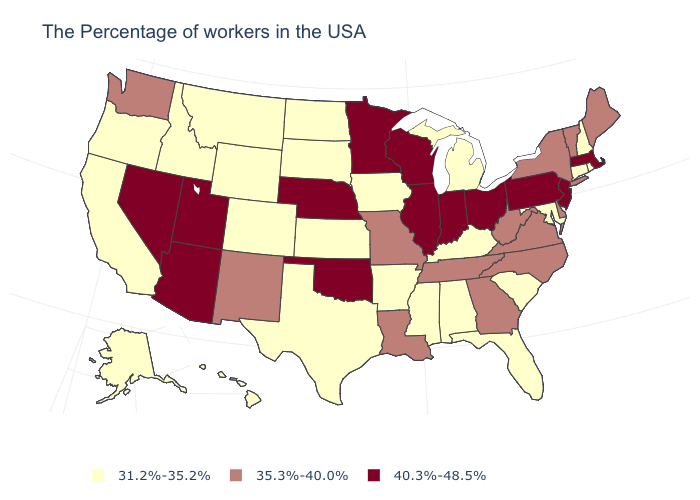What is the value of Connecticut?
Keep it brief. 31.2%-35.2%. What is the value of Mississippi?
Concise answer only. 31.2%-35.2%. What is the lowest value in the MidWest?
Write a very short answer. 31.2%-35.2%. Name the states that have a value in the range 31.2%-35.2%?
Write a very short answer. Rhode Island, New Hampshire, Connecticut, Maryland, South Carolina, Florida, Michigan, Kentucky, Alabama, Mississippi, Arkansas, Iowa, Kansas, Texas, South Dakota, North Dakota, Wyoming, Colorado, Montana, Idaho, California, Oregon, Alaska, Hawaii. Does New Jersey have the highest value in the Northeast?
Concise answer only. Yes. Name the states that have a value in the range 35.3%-40.0%?
Short answer required. Maine, Vermont, New York, Delaware, Virginia, North Carolina, West Virginia, Georgia, Tennessee, Louisiana, Missouri, New Mexico, Washington. What is the highest value in states that border Rhode Island?
Short answer required. 40.3%-48.5%. Name the states that have a value in the range 40.3%-48.5%?
Give a very brief answer. Massachusetts, New Jersey, Pennsylvania, Ohio, Indiana, Wisconsin, Illinois, Minnesota, Nebraska, Oklahoma, Utah, Arizona, Nevada. What is the highest value in the USA?
Quick response, please. 40.3%-48.5%. Name the states that have a value in the range 35.3%-40.0%?
Quick response, please. Maine, Vermont, New York, Delaware, Virginia, North Carolina, West Virginia, Georgia, Tennessee, Louisiana, Missouri, New Mexico, Washington. Name the states that have a value in the range 31.2%-35.2%?
Keep it brief. Rhode Island, New Hampshire, Connecticut, Maryland, South Carolina, Florida, Michigan, Kentucky, Alabama, Mississippi, Arkansas, Iowa, Kansas, Texas, South Dakota, North Dakota, Wyoming, Colorado, Montana, Idaho, California, Oregon, Alaska, Hawaii. What is the highest value in the USA?
Keep it brief. 40.3%-48.5%. Among the states that border New Hampshire , which have the lowest value?
Quick response, please. Maine, Vermont. What is the highest value in states that border Maryland?
Short answer required. 40.3%-48.5%. What is the lowest value in states that border Rhode Island?
Give a very brief answer. 31.2%-35.2%. 